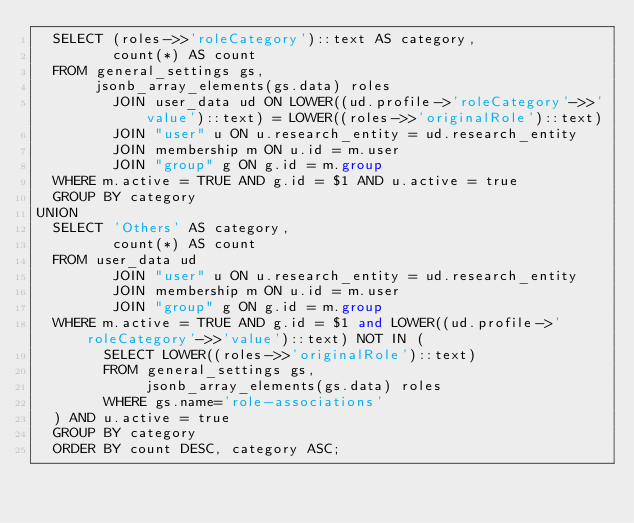Convert code to text. <code><loc_0><loc_0><loc_500><loc_500><_SQL_>  SELECT (roles->>'roleCategory')::text AS category,
         count(*) AS count
  FROM general_settings gs,
       jsonb_array_elements(gs.data) roles
         JOIN user_data ud ON LOWER((ud.profile->'roleCategory'->>'value')::text) = LOWER((roles->>'originalRole')::text)
         JOIN "user" u ON u.research_entity = ud.research_entity
         JOIN membership m ON u.id = m.user
         JOIN "group" g ON g.id = m.group
  WHERE m.active = TRUE AND g.id = $1 AND u.active = true
  GROUP BY category
UNION
  SELECT 'Others' AS category,
         count(*) AS count
  FROM user_data ud
         JOIN "user" u ON u.research_entity = ud.research_entity
         JOIN membership m ON u.id = m.user
         JOIN "group" g ON g.id = m.group
  WHERE m.active = TRUE AND g.id = $1 and LOWER((ud.profile->'roleCategory'->>'value')::text) NOT IN (
        SELECT LOWER((roles->>'originalRole')::text)
        FROM general_settings gs,
             jsonb_array_elements(gs.data) roles
        WHERE gs.name='role-associations'
  ) AND u.active = true
  GROUP BY category
  ORDER BY count DESC, category ASC;</code> 